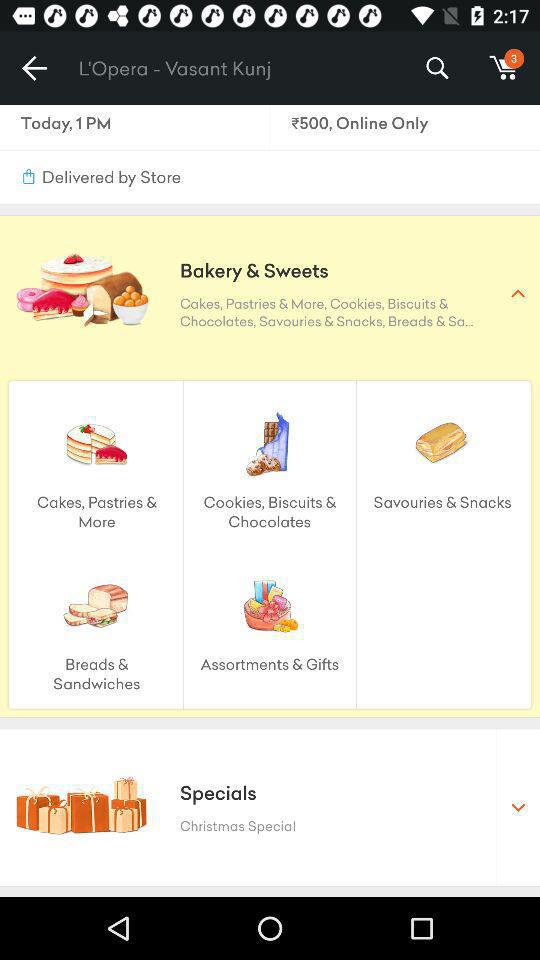How many orders are in the cart? There are three orders in the cart. 